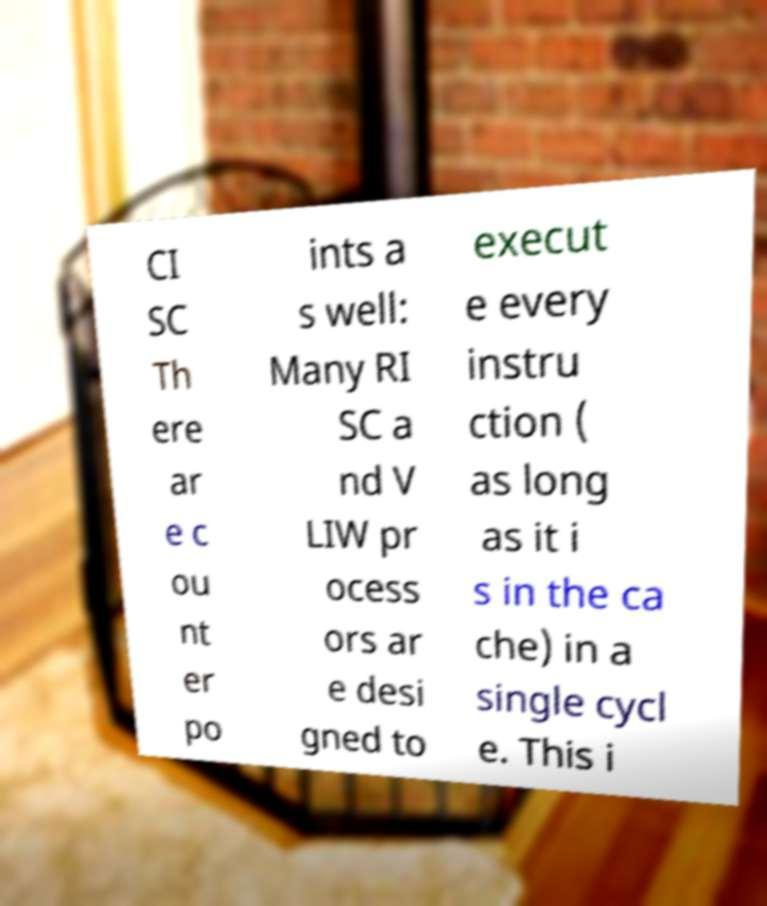Can you read and provide the text displayed in the image?This photo seems to have some interesting text. Can you extract and type it out for me? CI SC Th ere ar e c ou nt er po ints a s well: Many RI SC a nd V LIW pr ocess ors ar e desi gned to execut e every instru ction ( as long as it i s in the ca che) in a single cycl e. This i 